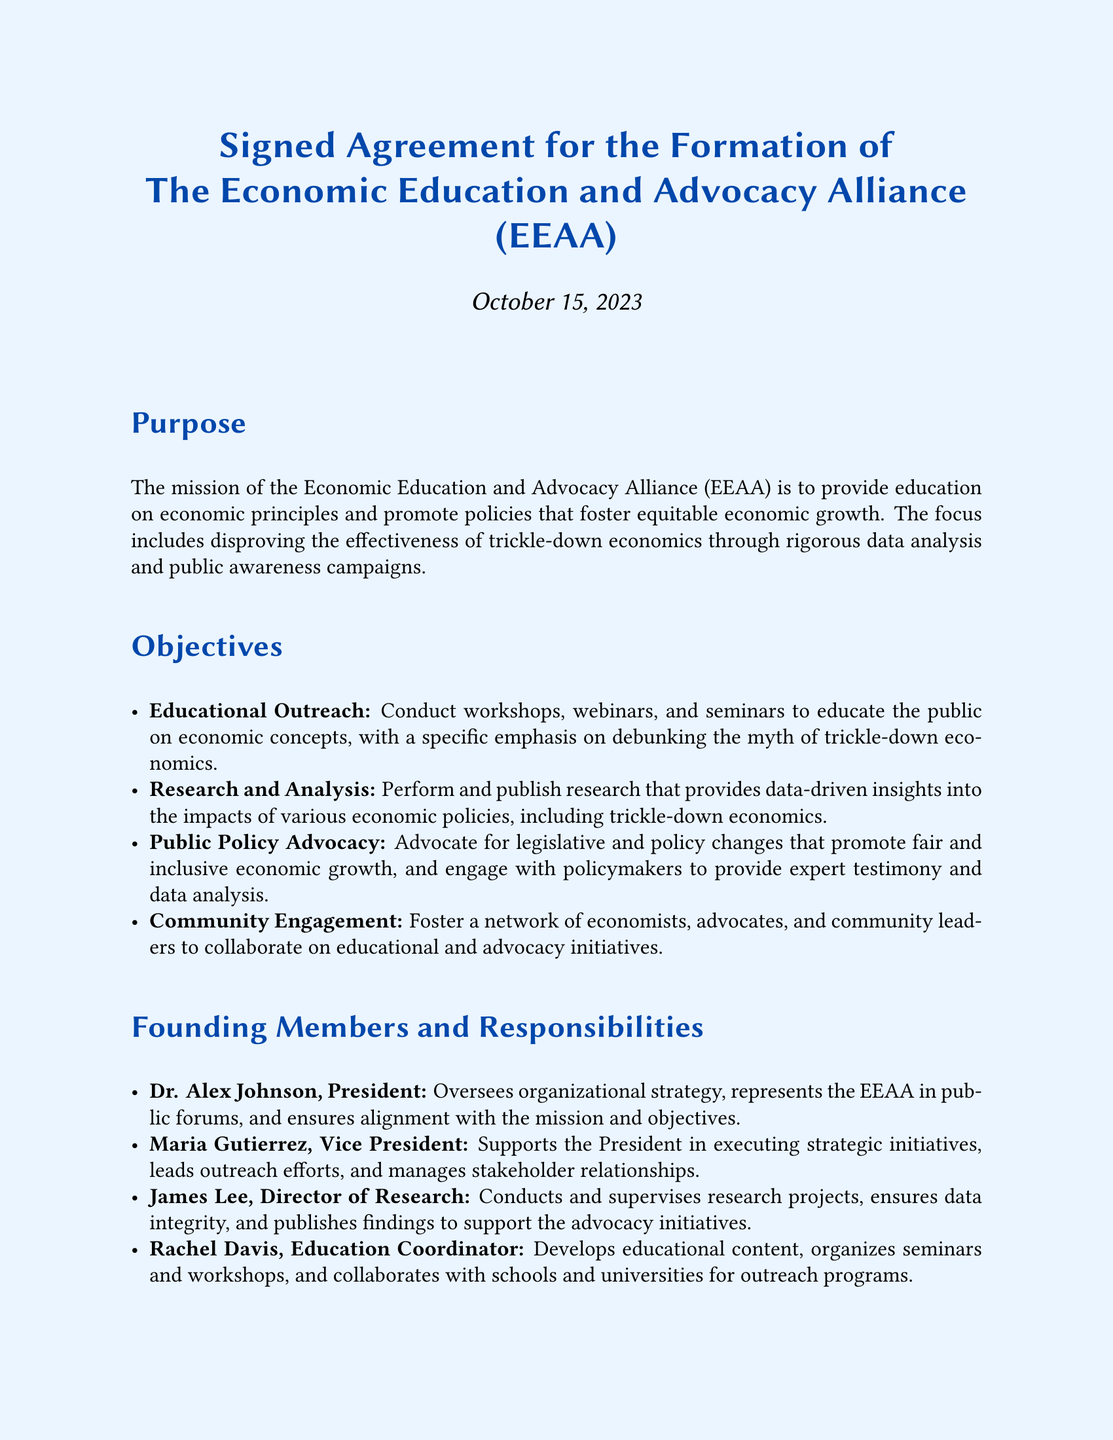What is the name of the organization being formed? The name of the organization is explicitly mentioned in the title of the document as the Economic Education and Advocacy Alliance.
Answer: Economic Education and Advocacy Alliance When was the agreement signed? The date of the agreement is noted at the top of the document, which states October 15, 2023.
Answer: October 15, 2023 Who is the President of the organization? The document lists Dr. Alex Johnson as the President among the founding members.
Answer: Dr. Alex Johnson What is one of the objectives related to community interaction? The document mentions "Community Engagement" as one of the objectives highlighting the focal point on networking with community leaders.
Answer: Community Engagement How many founding members are listed in the document? The document lists a total of four founding members with specified roles and responsibilities.
Answer: Four What role does Maria Gutierrez hold? The document explicitly identifies Maria Gutierrez as the Vice President of the organization.
Answer: Vice President What is the main focus of the organization according to its mission? The mission of the organization focuses on education and advocacy, particularly to debunk the effectiveness of trickle-down economics.
Answer: Economic principles education What type of organization is being established? The document defines the formation as a non-profit organization, which is indicated in the title section.
Answer: Non-Profit Organization What is the primary activity intended for educational outreach? The document specifies conducting workshops, webinars, and seminars as part of the educational outreach activities.
Answer: Workshops, webinars, and seminars 